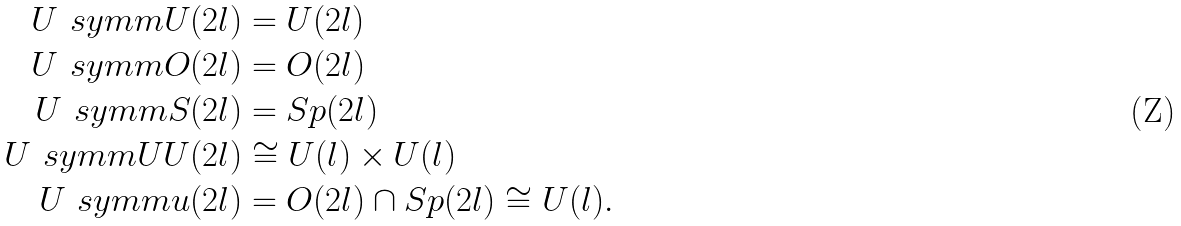Convert formula to latex. <formula><loc_0><loc_0><loc_500><loc_500>U ^ { \ } s y m m U ( 2 l ) & = U ( 2 l ) \\ U ^ { \ } s y m m O ( 2 l ) & = O ( 2 l ) \\ U ^ { \ } s y m m S ( 2 l ) & = S p ( 2 l ) \\ U ^ { \ } s y m m U U ( 2 l ) & \cong U ( l ) \times U ( l ) \\ U ^ { \ } s y m m u ( 2 l ) & = O ( 2 l ) \cap S p ( 2 l ) \cong U ( l ) .</formula> 